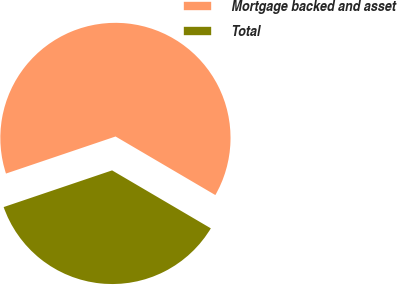Convert chart. <chart><loc_0><loc_0><loc_500><loc_500><pie_chart><fcel>Mortgage backed and asset<fcel>Total<nl><fcel>63.64%<fcel>36.36%<nl></chart> 